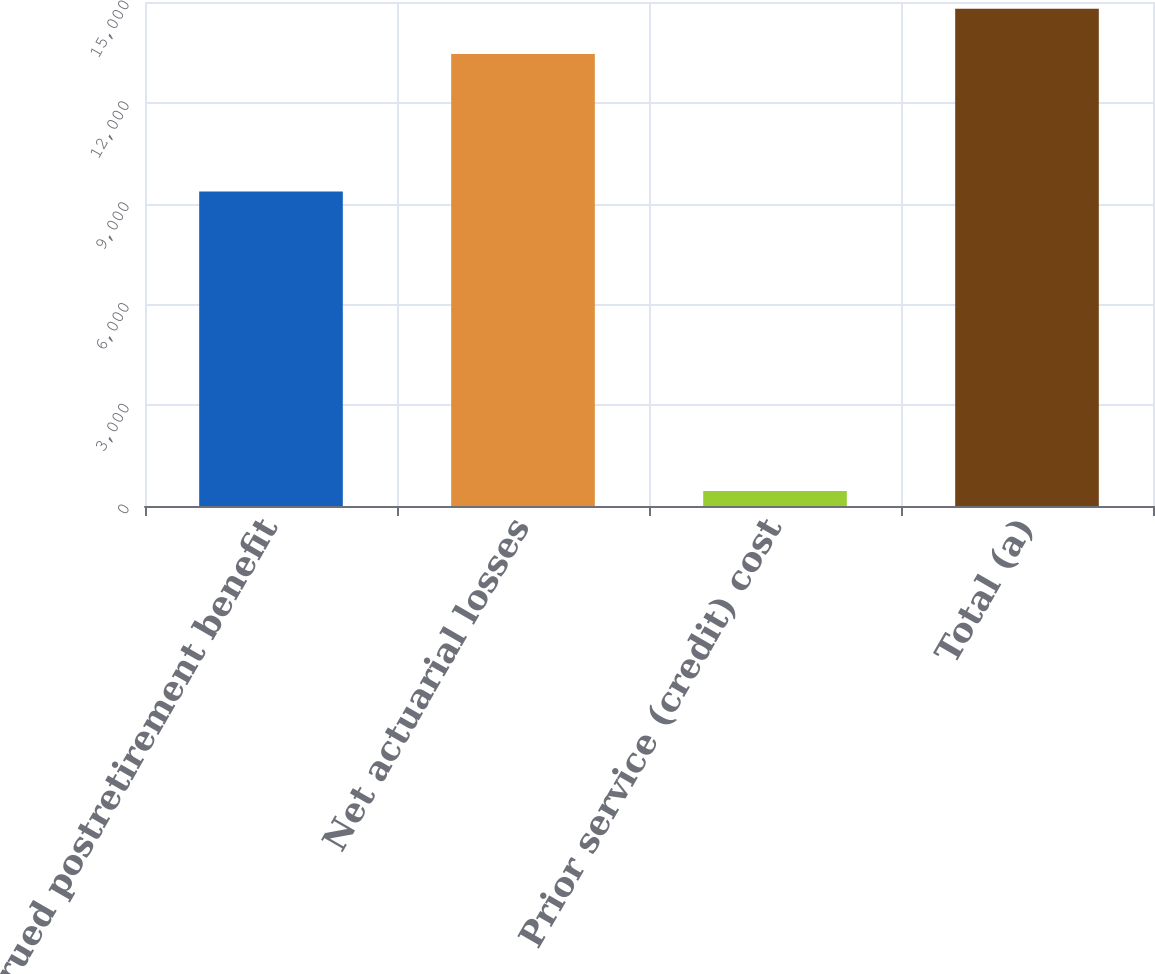Convert chart to OTSL. <chart><loc_0><loc_0><loc_500><loc_500><bar_chart><fcel>Accrued postretirement benefit<fcel>Net actuarial losses<fcel>Prior service (credit) cost<fcel>Total (a)<nl><fcel>9361<fcel>13453<fcel>443<fcel>14798.3<nl></chart> 